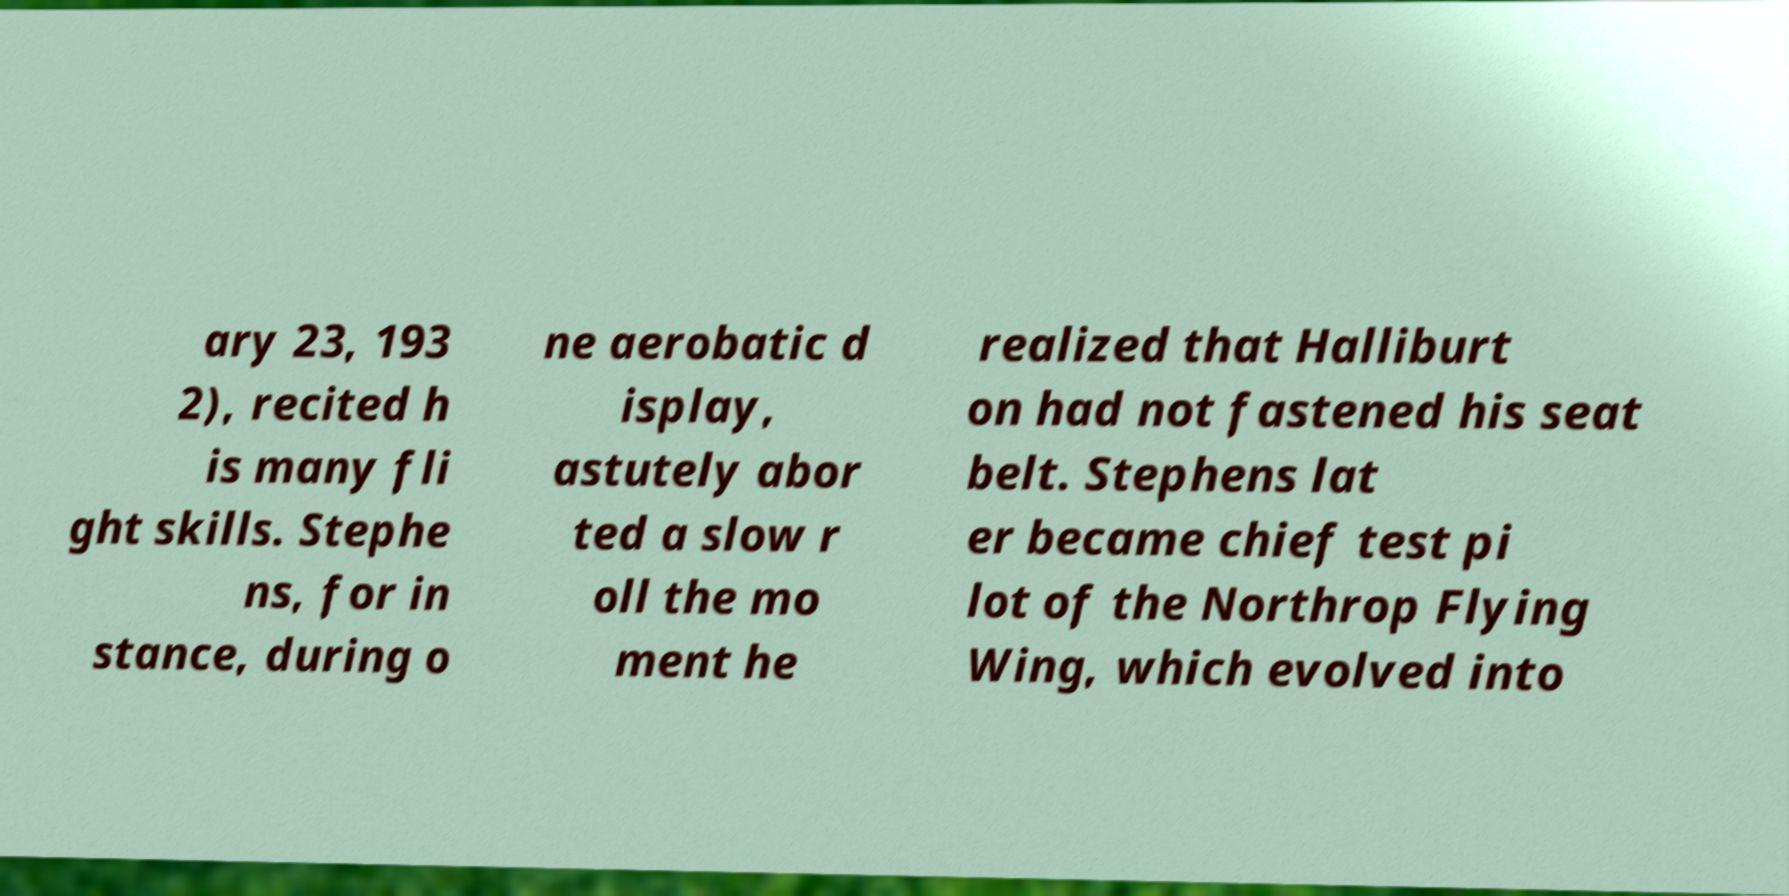What messages or text are displayed in this image? I need them in a readable, typed format. ary 23, 193 2), recited h is many fli ght skills. Stephe ns, for in stance, during o ne aerobatic d isplay, astutely abor ted a slow r oll the mo ment he realized that Halliburt on had not fastened his seat belt. Stephens lat er became chief test pi lot of the Northrop Flying Wing, which evolved into 